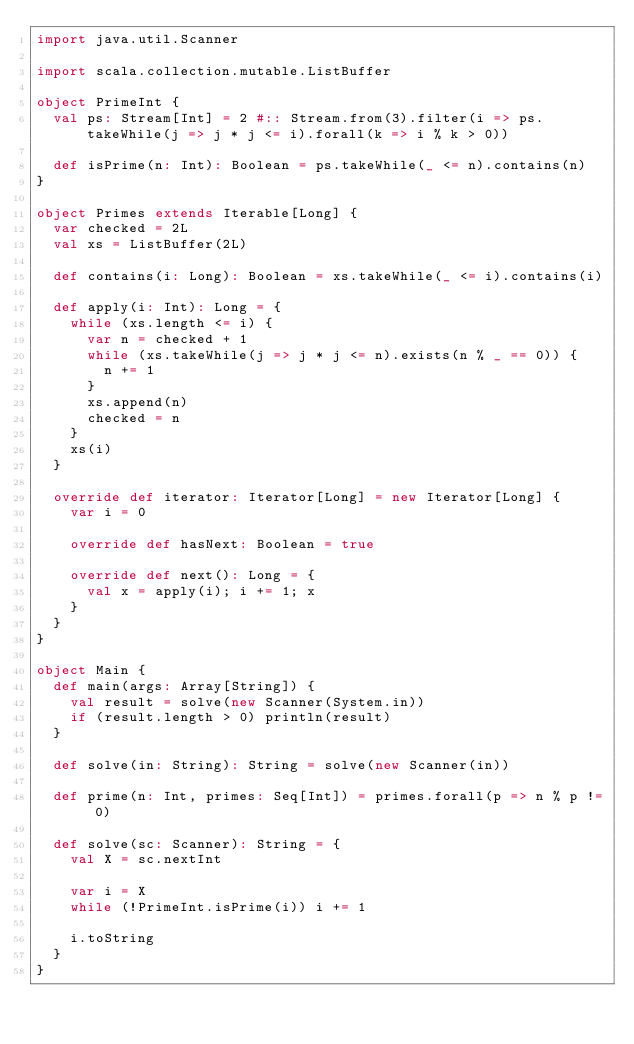Convert code to text. <code><loc_0><loc_0><loc_500><loc_500><_Scala_>import java.util.Scanner

import scala.collection.mutable.ListBuffer

object PrimeInt {
  val ps: Stream[Int] = 2 #:: Stream.from(3).filter(i => ps.takeWhile(j => j * j <= i).forall(k => i % k > 0))

  def isPrime(n: Int): Boolean = ps.takeWhile(_ <= n).contains(n)
}

object Primes extends Iterable[Long] {
  var checked = 2L
  val xs = ListBuffer(2L)

  def contains(i: Long): Boolean = xs.takeWhile(_ <= i).contains(i)

  def apply(i: Int): Long = {
    while (xs.length <= i) {
      var n = checked + 1
      while (xs.takeWhile(j => j * j <= n).exists(n % _ == 0)) {
        n += 1
      }
      xs.append(n)
      checked = n
    }
    xs(i)
  }

  override def iterator: Iterator[Long] = new Iterator[Long] {
    var i = 0

    override def hasNext: Boolean = true

    override def next(): Long = {
      val x = apply(i); i += 1; x
    }
  }
}

object Main {
  def main(args: Array[String]) {
    val result = solve(new Scanner(System.in))
    if (result.length > 0) println(result)
  }

  def solve(in: String): String = solve(new Scanner(in))

  def prime(n: Int, primes: Seq[Int]) = primes.forall(p => n % p != 0)

  def solve(sc: Scanner): String = {
    val X = sc.nextInt

    var i = X
    while (!PrimeInt.isPrime(i)) i += 1

    i.toString
  }
}
</code> 